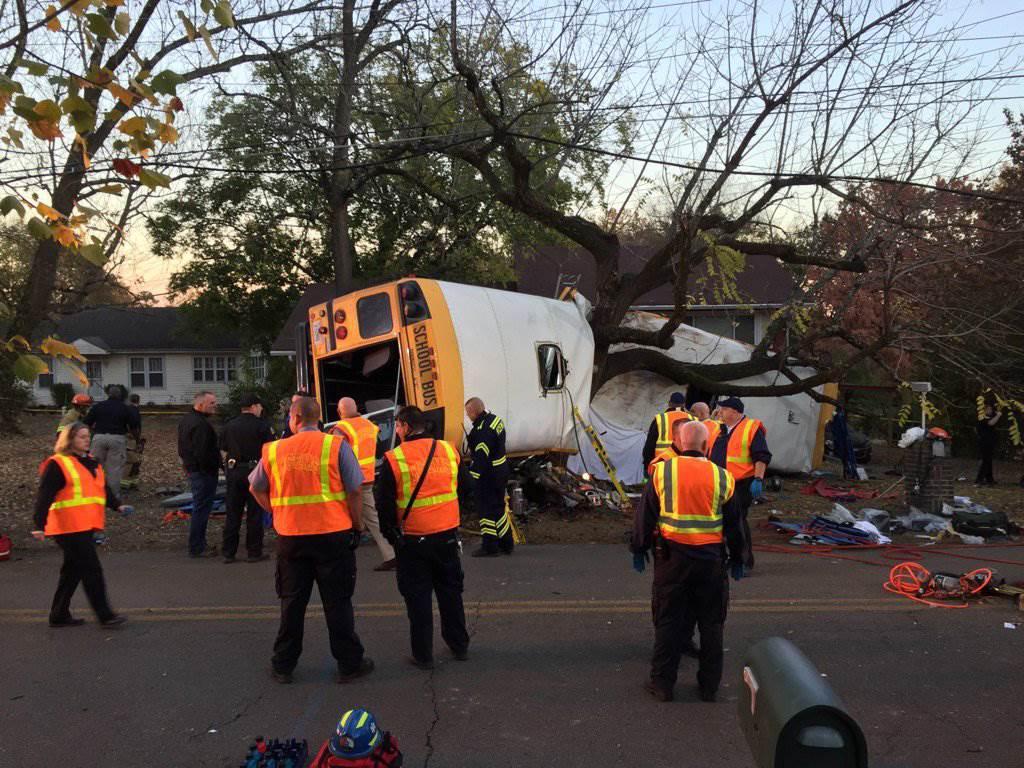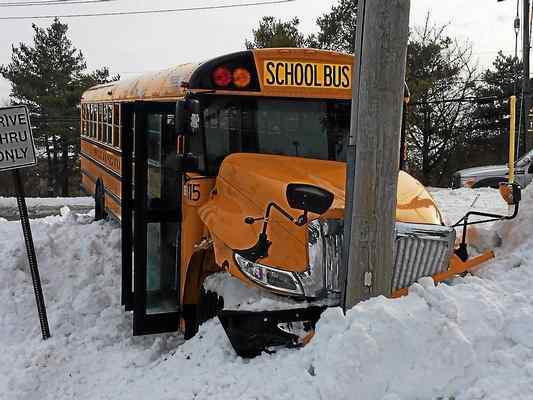The first image is the image on the left, the second image is the image on the right. Analyze the images presented: Is the assertion "A blue tarp covers the side of the bus in one of the images." valid? Answer yes or no. No. The first image is the image on the left, the second image is the image on the right. For the images shown, is this caption "there is a bus on the back of a flat bed tow truck" true? Answer yes or no. No. 